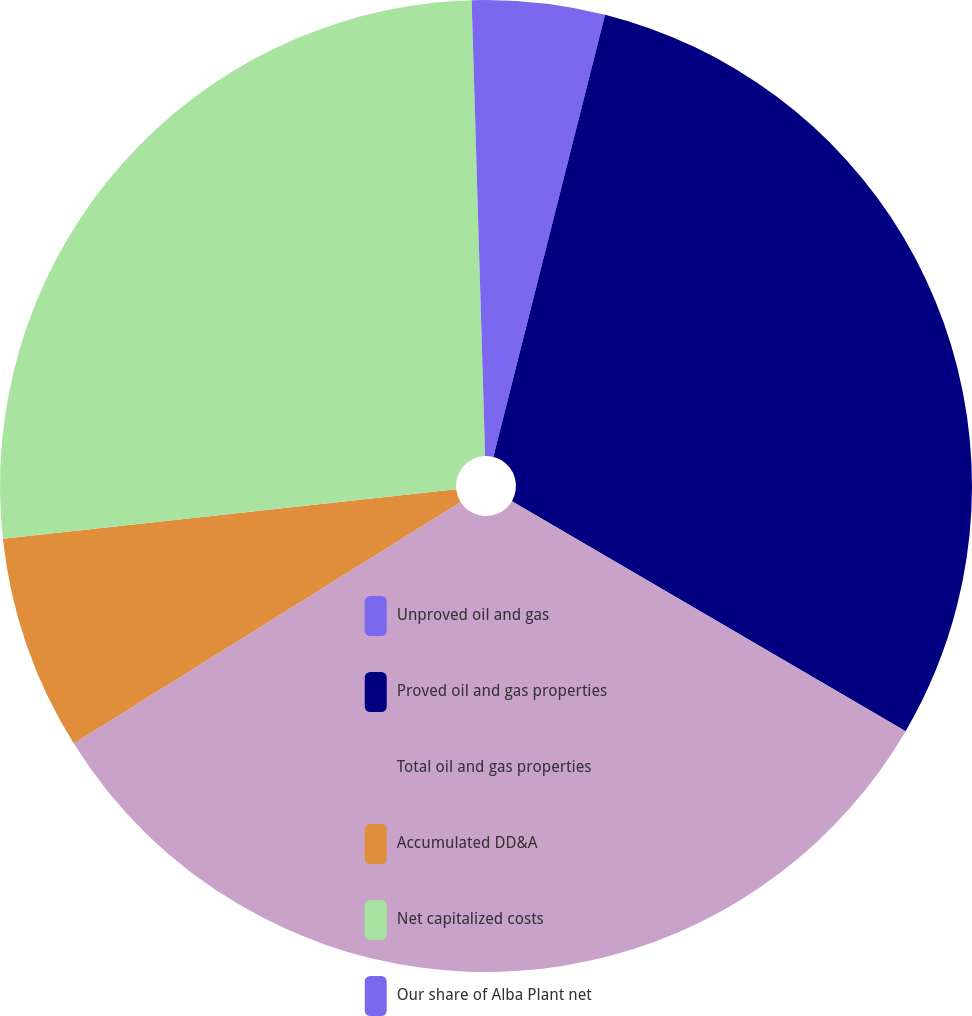Convert chart to OTSL. <chart><loc_0><loc_0><loc_500><loc_500><pie_chart><fcel>Unproved oil and gas<fcel>Proved oil and gas properties<fcel>Total oil and gas properties<fcel>Accumulated DD&A<fcel>Net capitalized costs<fcel>Our share of Alba Plant net<nl><fcel>3.94%<fcel>29.48%<fcel>32.7%<fcel>7.16%<fcel>26.26%<fcel>0.47%<nl></chart> 